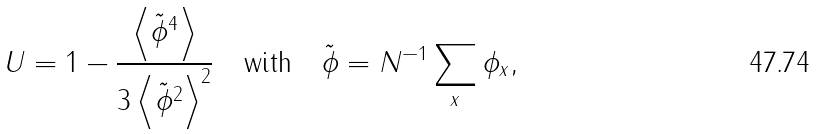<formula> <loc_0><loc_0><loc_500><loc_500>U = 1 - \frac { \left \langle \tilde { \phi } ^ { 4 } \right \rangle } { 3 \left \langle \tilde { \phi } ^ { 2 } \right \rangle ^ { 2 } } \quad \text {with} \quad \tilde { \phi } = N ^ { - 1 } \sum _ { x } \phi _ { x } ,</formula> 